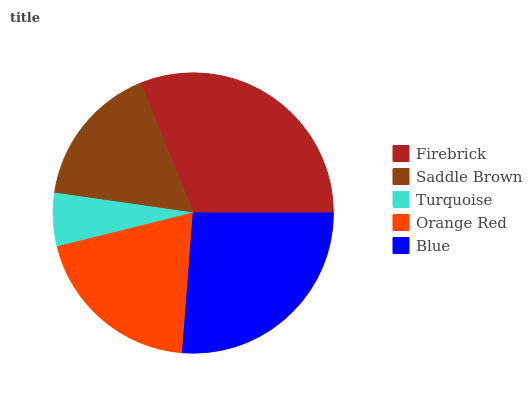Is Turquoise the minimum?
Answer yes or no. Yes. Is Firebrick the maximum?
Answer yes or no. Yes. Is Saddle Brown the minimum?
Answer yes or no. No. Is Saddle Brown the maximum?
Answer yes or no. No. Is Firebrick greater than Saddle Brown?
Answer yes or no. Yes. Is Saddle Brown less than Firebrick?
Answer yes or no. Yes. Is Saddle Brown greater than Firebrick?
Answer yes or no. No. Is Firebrick less than Saddle Brown?
Answer yes or no. No. Is Orange Red the high median?
Answer yes or no. Yes. Is Orange Red the low median?
Answer yes or no. Yes. Is Saddle Brown the high median?
Answer yes or no. No. Is Turquoise the low median?
Answer yes or no. No. 